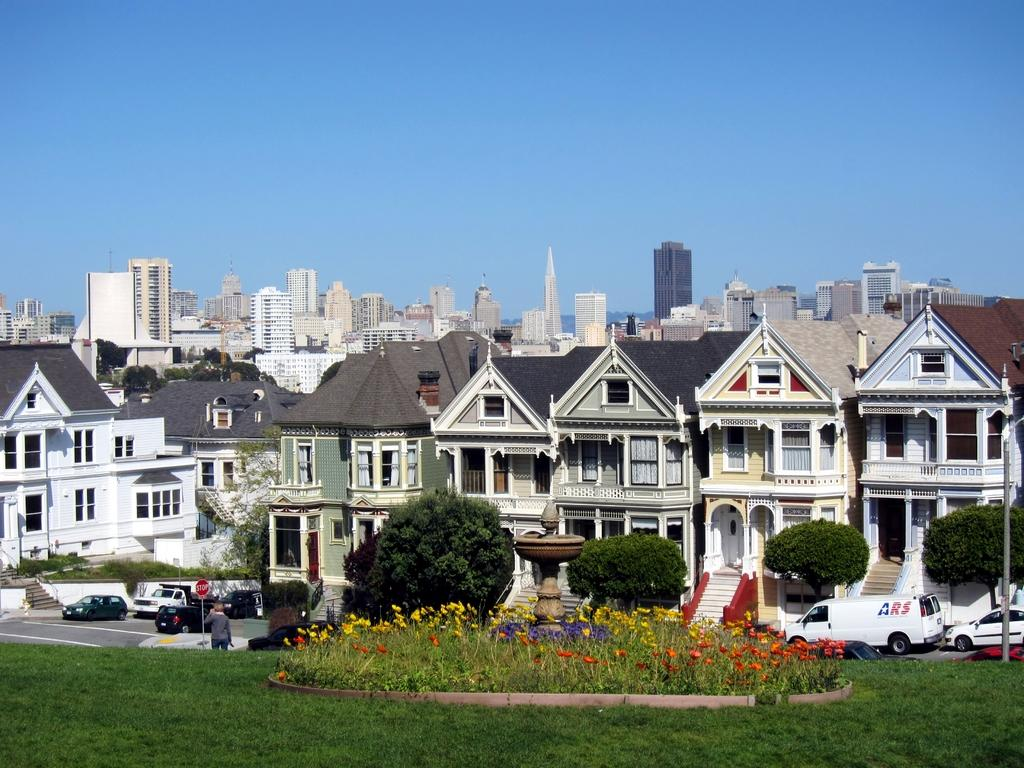What type of structures can be seen in the background of the image? There are buildings in the background of the image. What is present at the bottom of the image? There is grass and trees at the bottom of the image. What is moving along the road in the image? There are vehicles on the road. What can be seen at the top of the image? The sky is visible at the top of the image. Can you see a man pumping water in the image? There is no man pumping water present in the image. What type of show is being performed in the image? There is no show being performed in the image; it features buildings, grass, trees, vehicles, and the sky. 